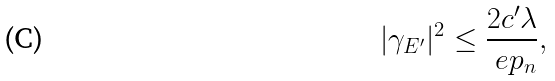<formula> <loc_0><loc_0><loc_500><loc_500>| \gamma _ { E ^ { \prime } } | ^ { 2 } \leq \frac { 2 c ^ { \prime } \lambda } { \ e p _ { n } } ,</formula> 